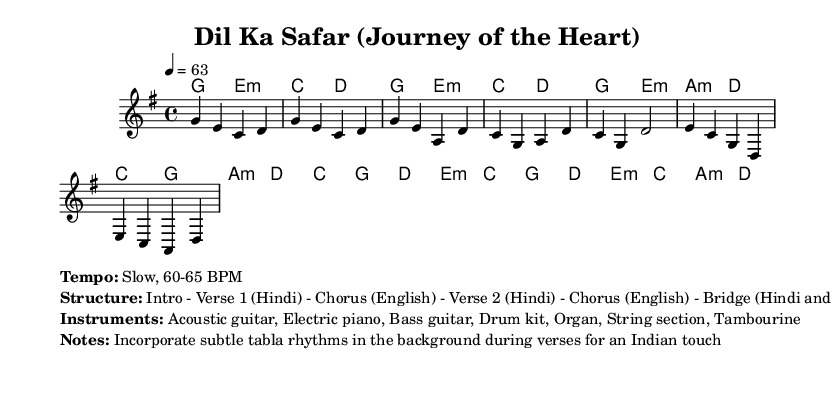What is the key signature of this music? The key signature indicates G major, which has one sharp (F#). This can be deduced from the global section of the provided code.
Answer: G major What is the time signature of this music? The time signature of the piece is 4/4, which means there are four beats in each measure. This is also specified in the global section of the code.
Answer: 4/4 What is the tempo marking for this piece? The tempo is indicated as 4 = 63, meaning the quarter note is set at a speed of 63 beats per minute, reflecting a slow pace. This is found in the global section.
Answer: 63 BPM How many verses are there in the structure? The structure of the song includes two verses. The layout structure specific to the song indicates Verse 1 and Verse 2, mentioned explicitly in the markup section.
Answer: 2 What instruments are used in this arrangement? The music arrangement includes acoustic guitar, electric piano, bass guitar, drum kit, organ, string section, and tambourine, as detailed in the markup information.
Answer: Acoustic guitar, Electric piano, Bass guitar, Drum kit, Organ, String section, Tambourine In which languages are the lyrics sung in the verses? The verses are sung in Hindi, as specified in the structure outline from the markup section, indicating a blend of Hindi and English throughout the song.
Answer: Hindi What is the specific characteristic of the rhythm mentioned for the verses? A specific characteristic includes incorporating subtle tabla rhythms in the background during the verses, providing an Indian touch. This is highlighted in the notes of the markup section.
Answer: Subtle tabla rhythms 